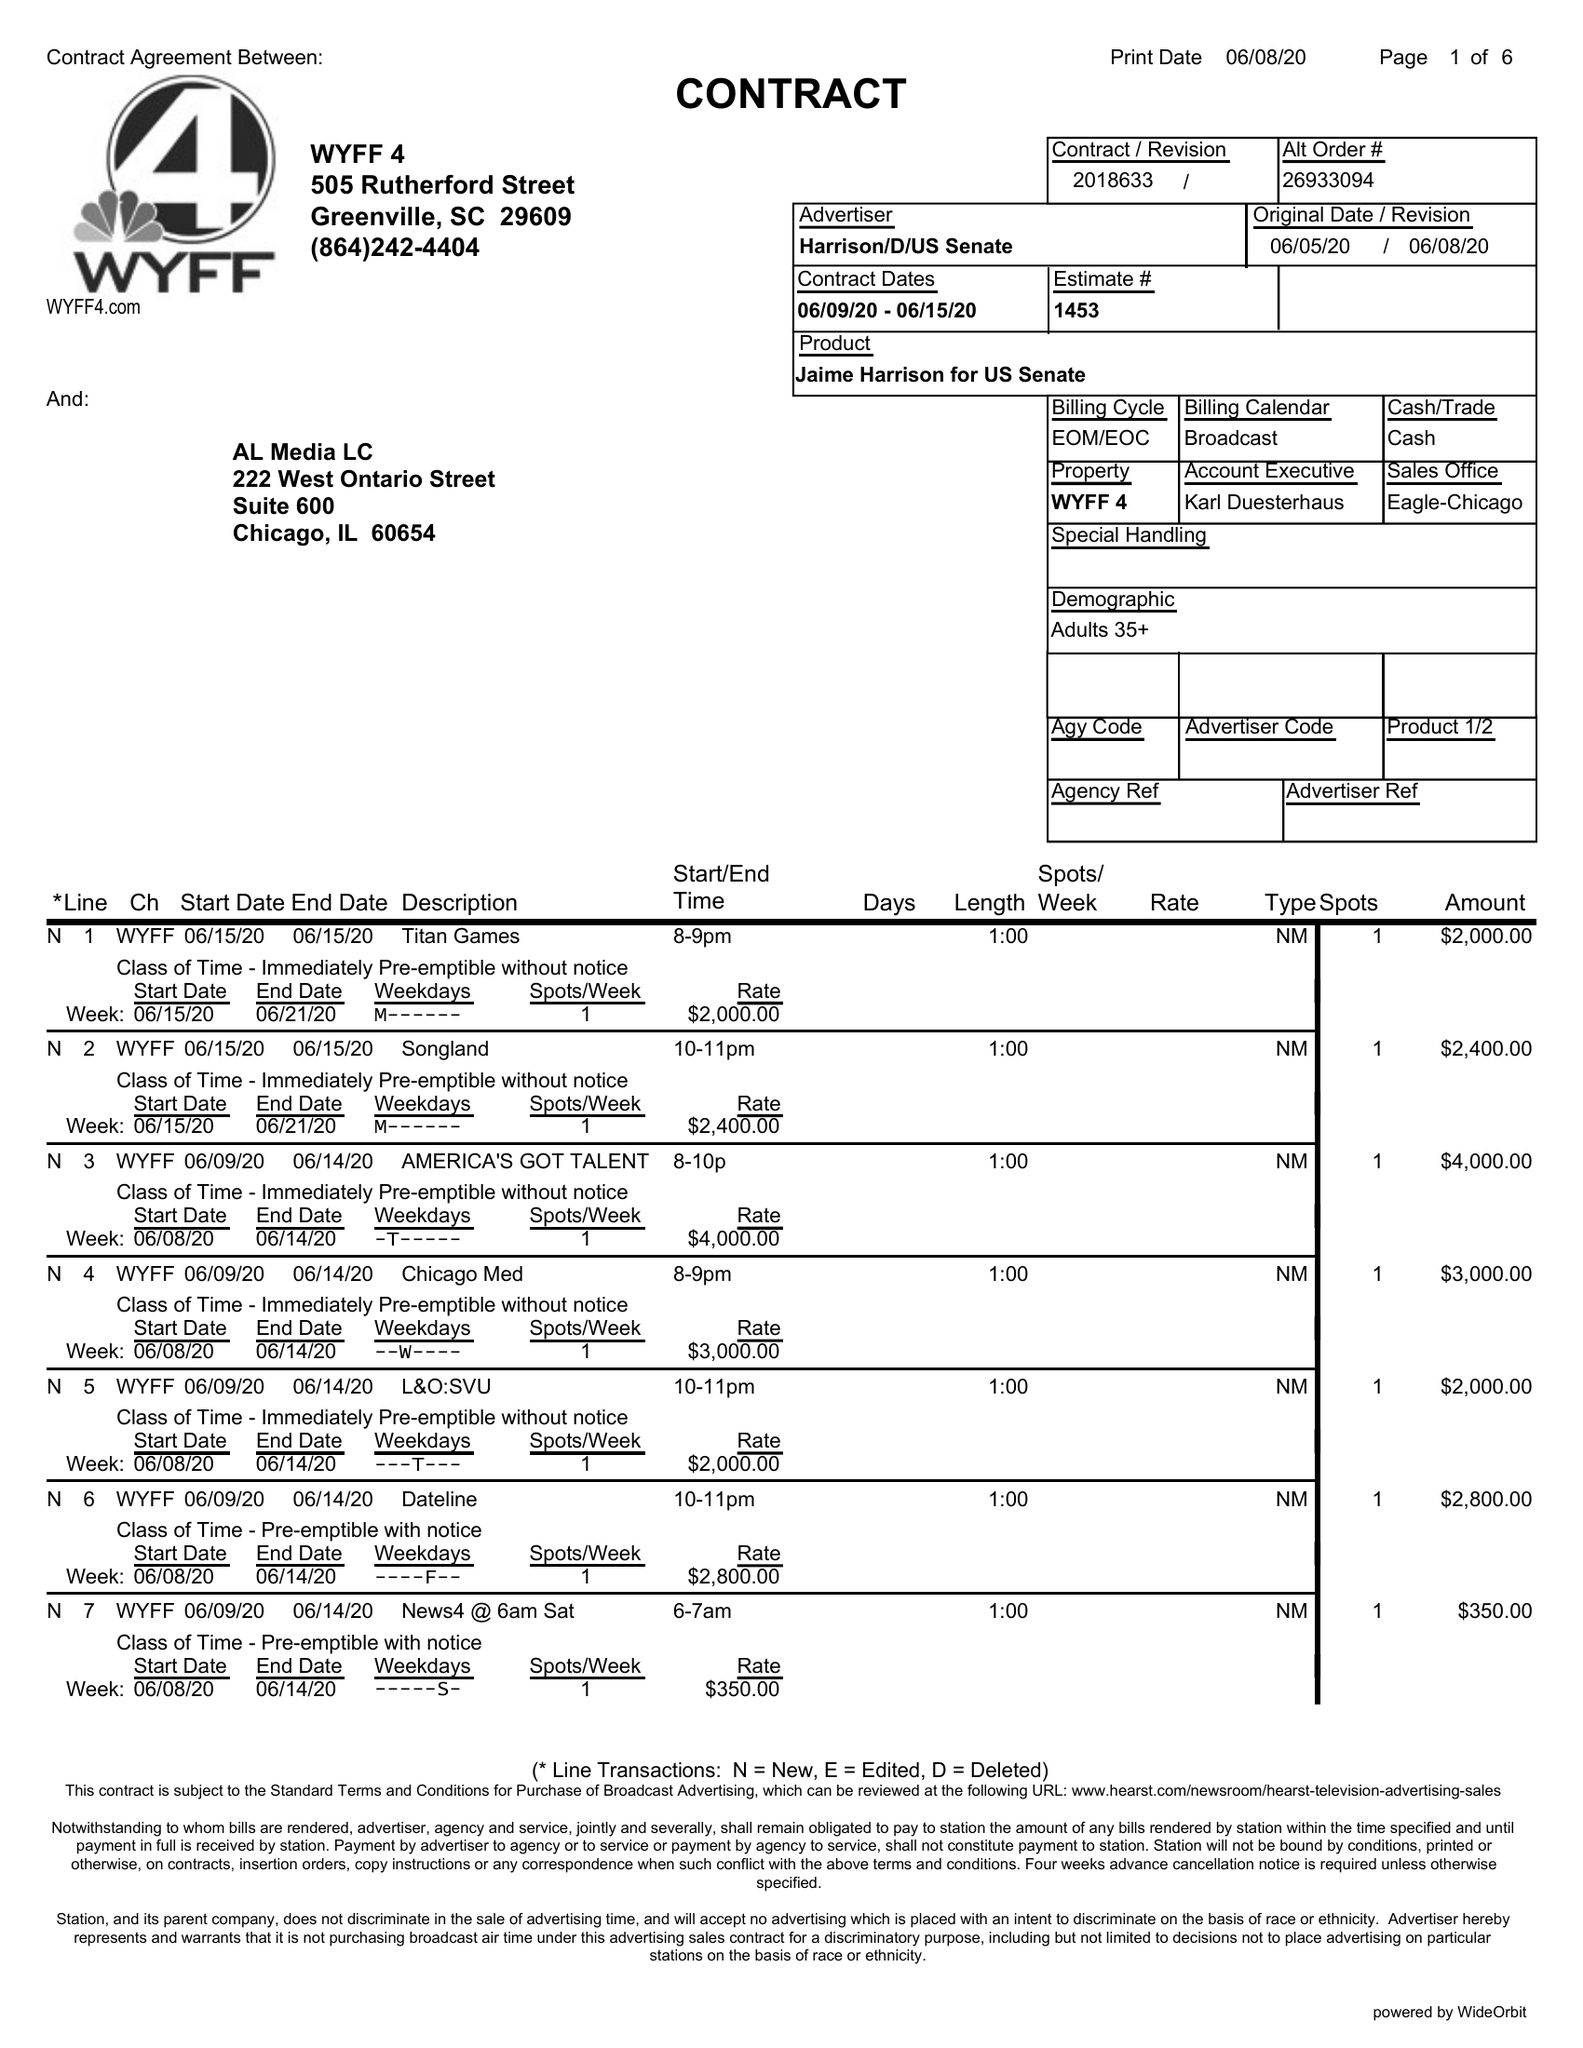What is the value for the flight_from?
Answer the question using a single word or phrase. 06/08/20 